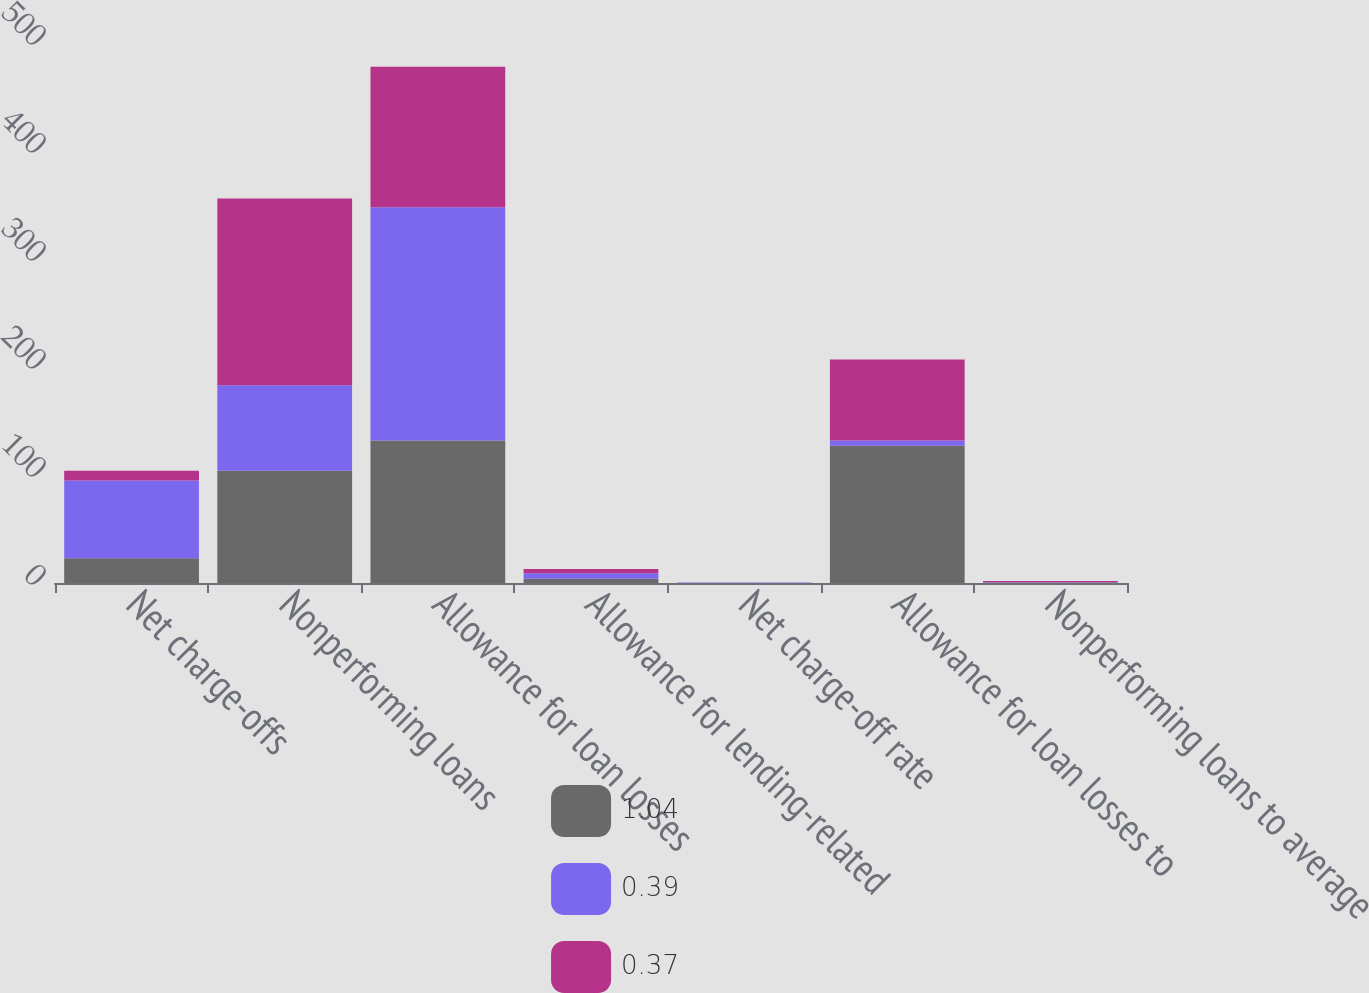Convert chart to OTSL. <chart><loc_0><loc_0><loc_500><loc_500><stacked_bar_chart><ecel><fcel>Net charge-offs<fcel>Nonperforming loans<fcel>Allowance for loan losses<fcel>Allowance for lending-related<fcel>Net charge-off rate<fcel>Allowance for loan losses to<fcel>Nonperforming loans to average<nl><fcel>1.04<fcel>23<fcel>104<fcel>132<fcel>4<fcel>0.09<fcel>127<fcel>0.39<nl><fcel>0.39<fcel>72<fcel>79<fcel>216<fcel>5<fcel>0.33<fcel>5<fcel>0.37<nl><fcel>0.37<fcel>9<fcel>173<fcel>130<fcel>4<fcel>0.05<fcel>75<fcel>1.04<nl></chart> 